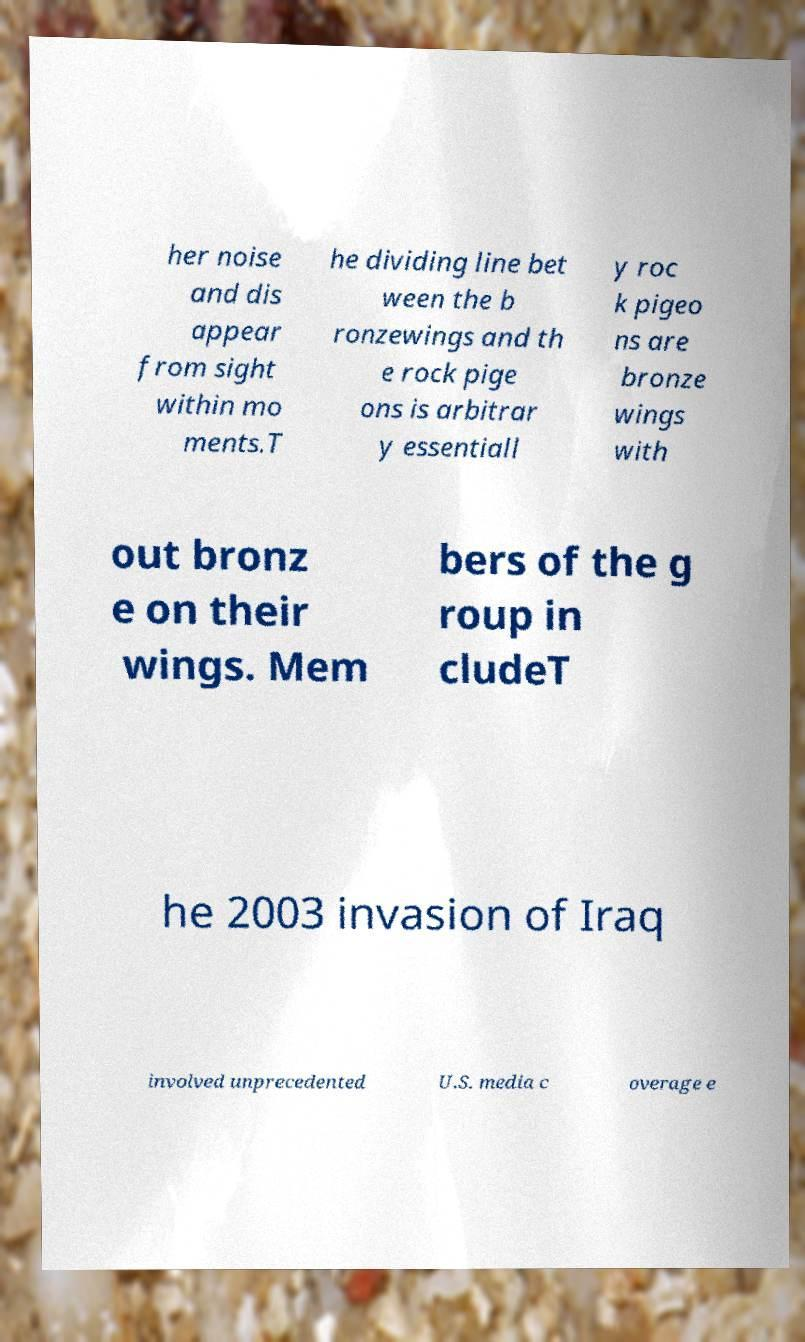Can you read and provide the text displayed in the image?This photo seems to have some interesting text. Can you extract and type it out for me? her noise and dis appear from sight within mo ments.T he dividing line bet ween the b ronzewings and th e rock pige ons is arbitrar y essentiall y roc k pigeo ns are bronze wings with out bronz e on their wings. Mem bers of the g roup in cludeT he 2003 invasion of Iraq involved unprecedented U.S. media c overage e 